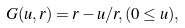<formula> <loc_0><loc_0><loc_500><loc_500>G ( u , r ) = r - u / r , ( 0 \leq u ) ,</formula> 